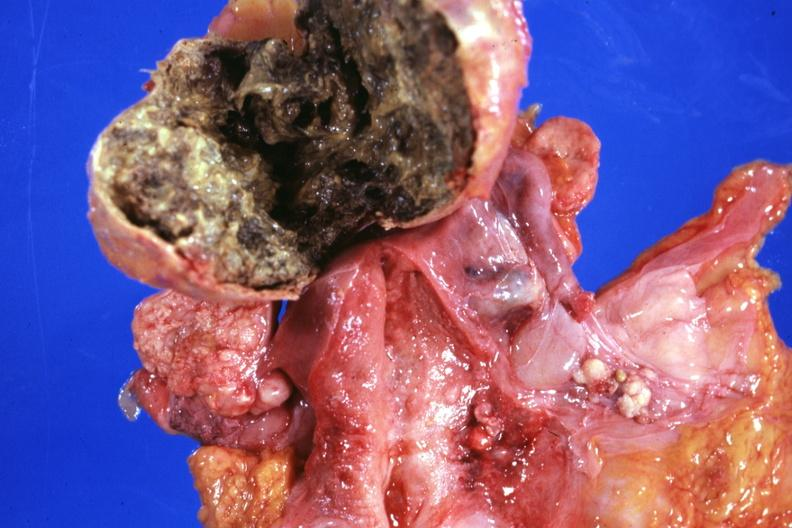s ovary present?
Answer the question using a single word or phrase. Yes 